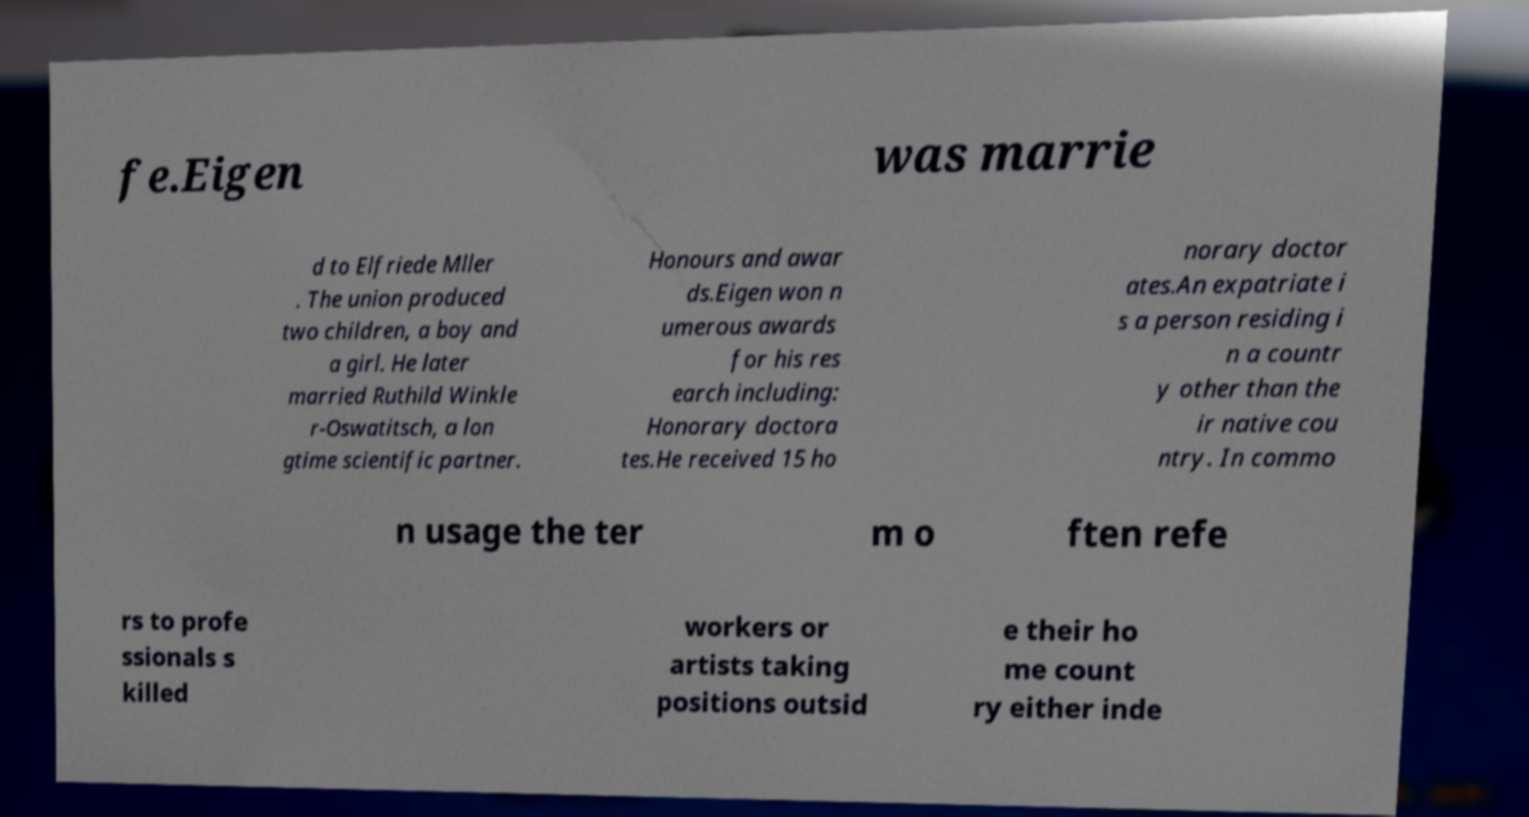Could you extract and type out the text from this image? fe.Eigen was marrie d to Elfriede Mller . The union produced two children, a boy and a girl. He later married Ruthild Winkle r-Oswatitsch, a lon gtime scientific partner. Honours and awar ds.Eigen won n umerous awards for his res earch including: Honorary doctora tes.He received 15 ho norary doctor ates.An expatriate i s a person residing i n a countr y other than the ir native cou ntry. In commo n usage the ter m o ften refe rs to profe ssionals s killed workers or artists taking positions outsid e their ho me count ry either inde 